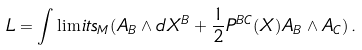<formula> <loc_0><loc_0><loc_500><loc_500>L = \int \lim i t s _ { M } ( A _ { B } \wedge d X ^ { B } + \frac { 1 } { 2 } P ^ { B C } ( X ) A _ { B } \wedge A _ { C } ) \, .</formula> 